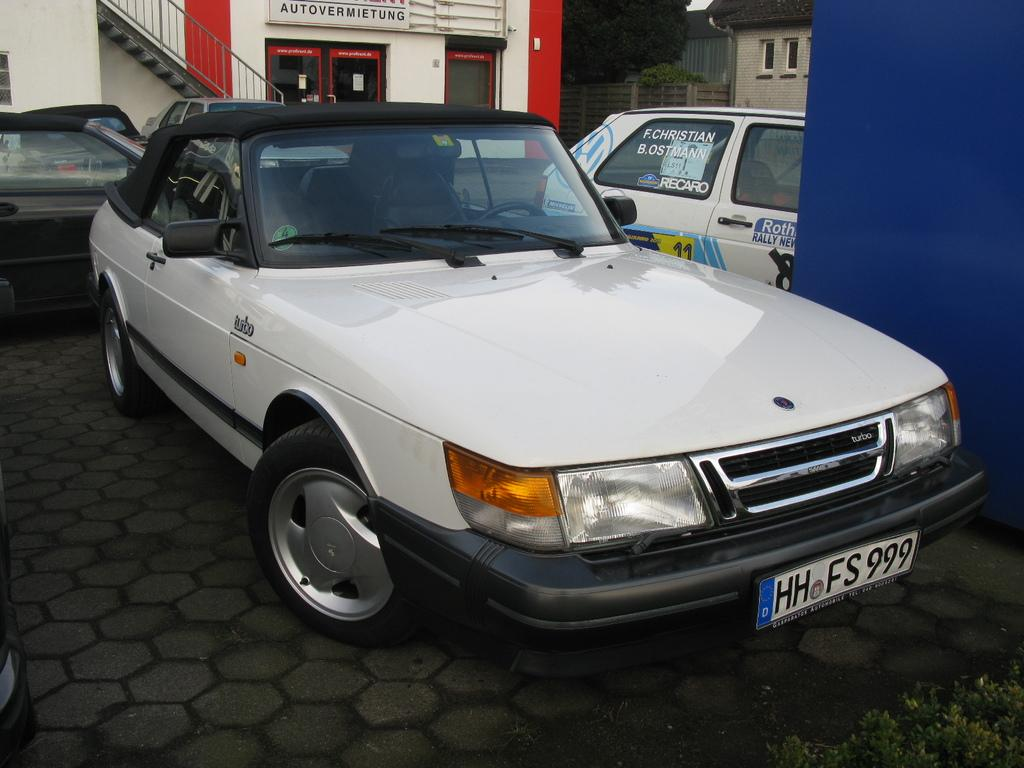What types of structures are present in the image? There are vehicles, houses, trees, stairs, and a fence in the image. Can you describe the landscape in the image? The image features a combination of structures and natural elements, including houses, trees, and a fence. What architectural feature can be seen in the image? There are stairs visible in the image. What type of pot is being used to perform addition in the image? There is no pot or addition being performed in the image. How does the fence in the image get washed? The image does not show any washing or cleaning of the fence; it is a static image. 